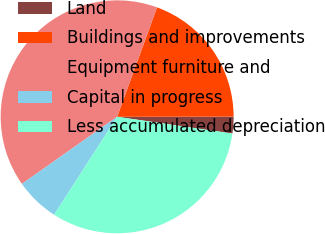<chart> <loc_0><loc_0><loc_500><loc_500><pie_chart><fcel>Land<fcel>Buildings and improvements<fcel>Equipment furniture and<fcel>Capital in progress<fcel>Less accumulated depreciation<nl><fcel>2.33%<fcel>19.4%<fcel>40.33%<fcel>6.13%<fcel>31.8%<nl></chart> 